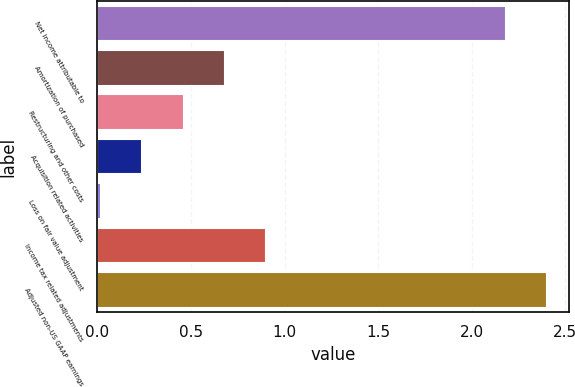<chart> <loc_0><loc_0><loc_500><loc_500><bar_chart><fcel>Net income attributable to<fcel>Amortization of purchased<fcel>Restructuring and other costs<fcel>Acquisition related activities<fcel>Loss on fair value adjustment<fcel>Income tax related adjustments<fcel>Adjusted non-US GAAP earnings<nl><fcel>2.18<fcel>0.68<fcel>0.46<fcel>0.24<fcel>0.02<fcel>0.9<fcel>2.4<nl></chart> 